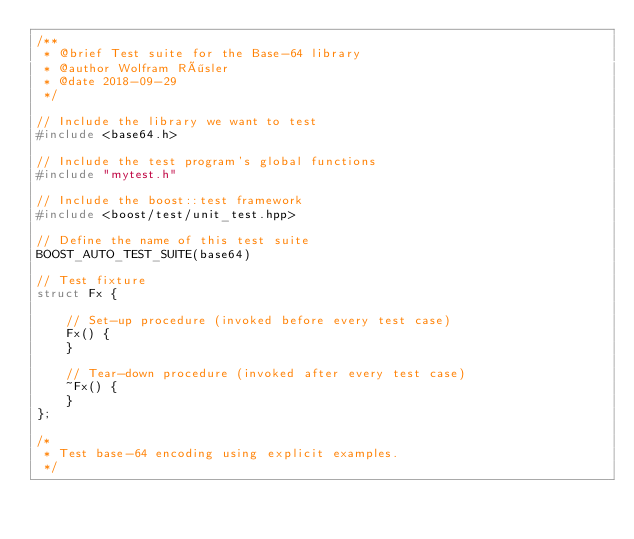<code> <loc_0><loc_0><loc_500><loc_500><_C++_>/**
 * @brief Test suite for the Base-64 library
 * @author Wolfram Rösler
 * @date 2018-09-29
 */

// Include the library we want to test
#include <base64.h>

// Include the test program's global functions
#include "mytest.h"

// Include the boost::test framework
#include <boost/test/unit_test.hpp>

// Define the name of this test suite
BOOST_AUTO_TEST_SUITE(base64)

// Test fixture
struct Fx {

    // Set-up procedure (invoked before every test case)
    Fx() {
    }

    // Tear-down procedure (invoked after every test case)
    ~Fx() {
    }
};

/*
 * Test base-64 encoding using explicit examples.
 */</code> 